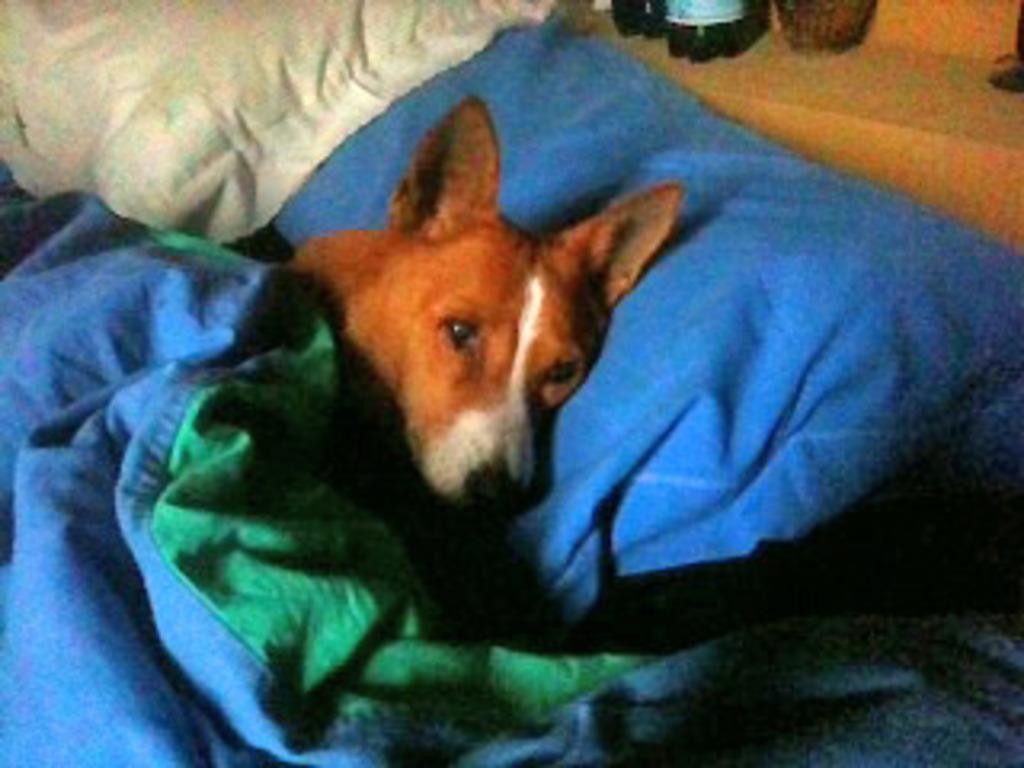Can you describe this image briefly? In this image we can see a dog lying on the pillow covered with a blanket. 